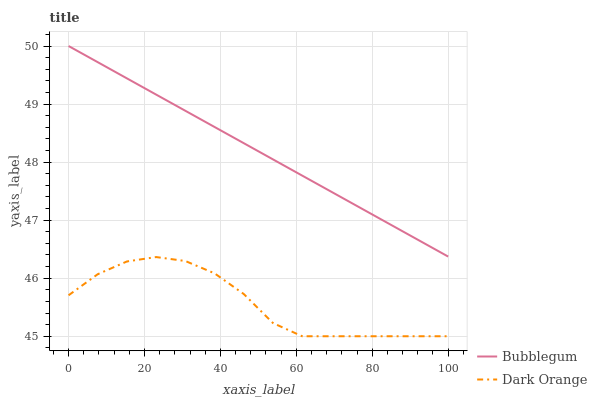Does Dark Orange have the minimum area under the curve?
Answer yes or no. Yes. Does Bubblegum have the maximum area under the curve?
Answer yes or no. Yes. Does Bubblegum have the minimum area under the curve?
Answer yes or no. No. Is Bubblegum the smoothest?
Answer yes or no. Yes. Is Dark Orange the roughest?
Answer yes or no. Yes. Is Bubblegum the roughest?
Answer yes or no. No. Does Dark Orange have the lowest value?
Answer yes or no. Yes. Does Bubblegum have the lowest value?
Answer yes or no. No. Does Bubblegum have the highest value?
Answer yes or no. Yes. Is Dark Orange less than Bubblegum?
Answer yes or no. Yes. Is Bubblegum greater than Dark Orange?
Answer yes or no. Yes. Does Dark Orange intersect Bubblegum?
Answer yes or no. No. 